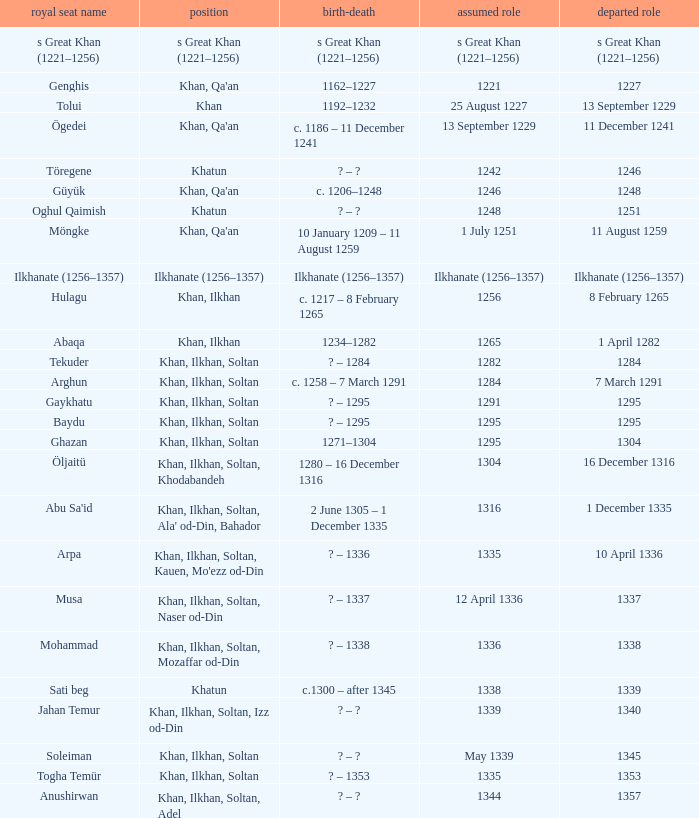What is the born-died that has office of 13 September 1229 as the entered? C. 1186 – 11 december 1241. 